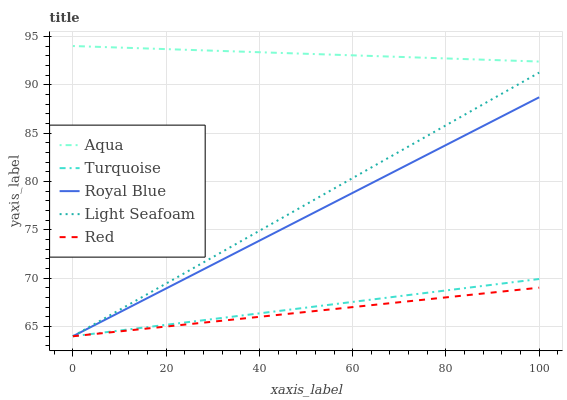Does Red have the minimum area under the curve?
Answer yes or no. Yes. Does Aqua have the maximum area under the curve?
Answer yes or no. Yes. Does Turquoise have the minimum area under the curve?
Answer yes or no. No. Does Turquoise have the maximum area under the curve?
Answer yes or no. No. Is Red the smoothest?
Answer yes or no. Yes. Is Light Seafoam the roughest?
Answer yes or no. Yes. Is Turquoise the smoothest?
Answer yes or no. No. Is Turquoise the roughest?
Answer yes or no. No. Does Royal Blue have the lowest value?
Answer yes or no. Yes. Does Aqua have the lowest value?
Answer yes or no. No. Does Aqua have the highest value?
Answer yes or no. Yes. Does Turquoise have the highest value?
Answer yes or no. No. Is Royal Blue less than Aqua?
Answer yes or no. Yes. Is Aqua greater than Turquoise?
Answer yes or no. Yes. Does Light Seafoam intersect Red?
Answer yes or no. Yes. Is Light Seafoam less than Red?
Answer yes or no. No. Is Light Seafoam greater than Red?
Answer yes or no. No. Does Royal Blue intersect Aqua?
Answer yes or no. No. 